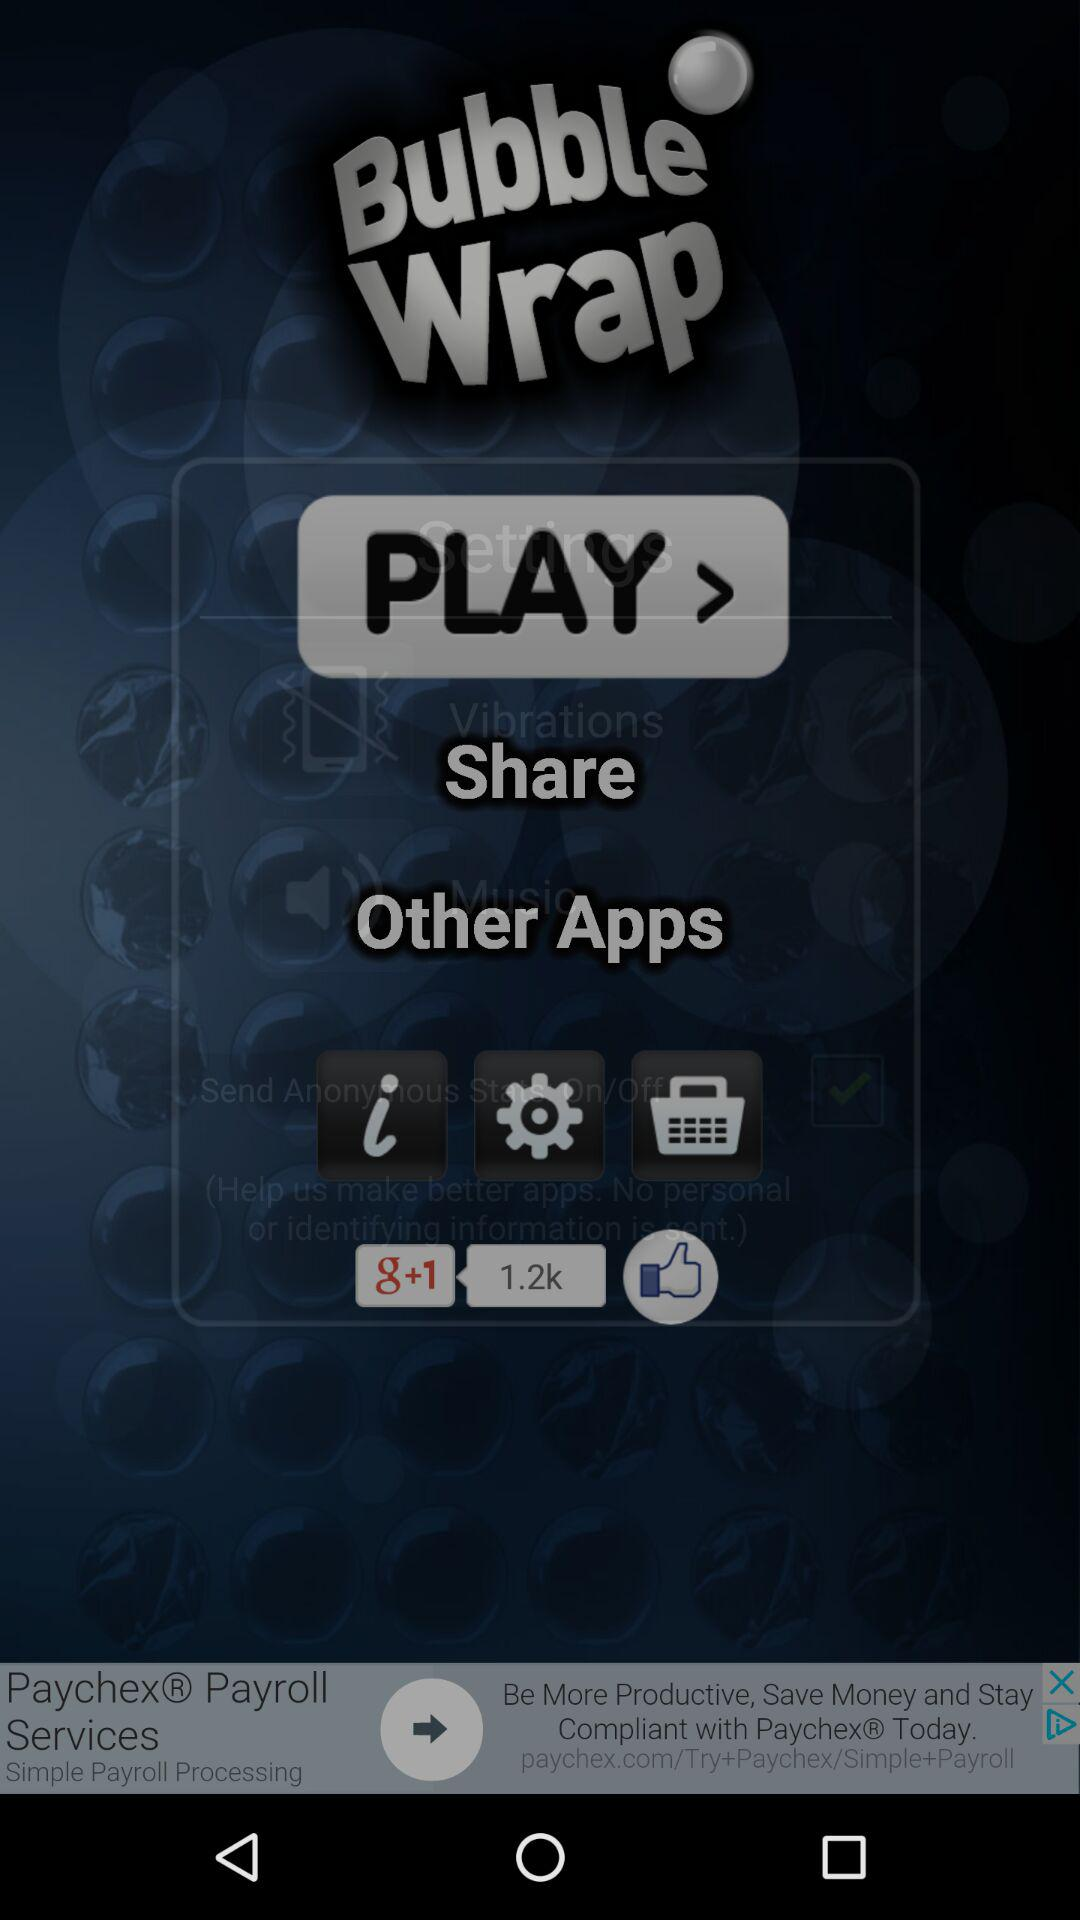How many people have liked "Bubble Wrap" on "g+1"? There are 1.2k people who have liked "Bubble Wrap" on "g+1". 